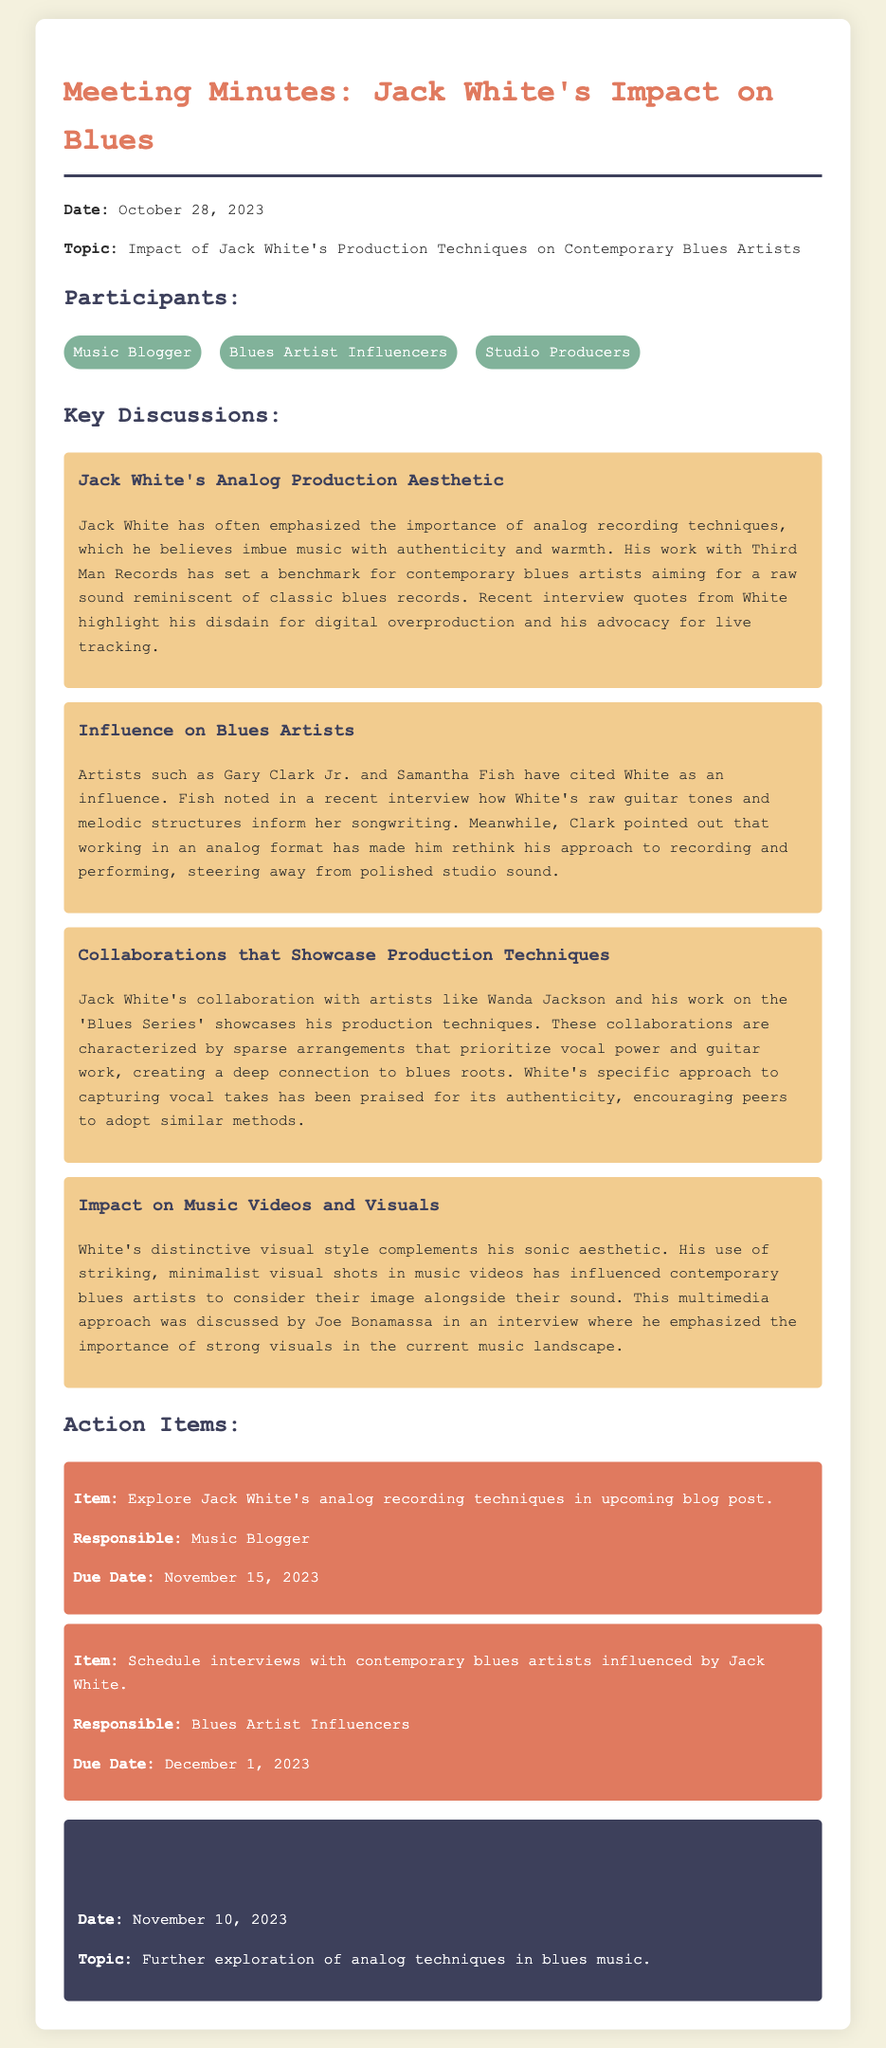what is the date of the meeting? The date of the meeting is mentioned at the beginning of the document.
Answer: October 28, 2023 who is one of the participants listed? The participants are displayed in a section of the document dedicated to listing them.
Answer: Music Blogger what production format does Jack White advocate for? The document discusses Jack White's preference for a certain production format.
Answer: Analog which artist cited Jack White as an influence in a recent interview? The discussion mentions artists who have cited Jack White as an influence and provides details.
Answer: Samantha Fish what is the due date for the action item assigned to the Music Blogger? The action item has a specific due date listed in the document.
Answer: November 15, 2023 which collaboration is highlighted as showcasing Jack White's production techniques? The document references specific collaborations to illustrate White's influence on production techniques.
Answer: Wanda Jackson what is the topic of the next meeting? The document specifies the topic for the next meeting at the bottom.
Answer: Further exploration of analog techniques in blues music how does Jack White's visual style influence contemporary blues artists? The discussion points to the effect of visual style on artists, detailed in the document.
Answer: Striking, minimalist visual shots which artist emphasized the importance of strong visuals in an interview? The document provides a specific artist's name who discussed visuals in music.
Answer: Joe Bonamassa 